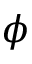Convert formula to latex. <formula><loc_0><loc_0><loc_500><loc_500>\phi</formula> 